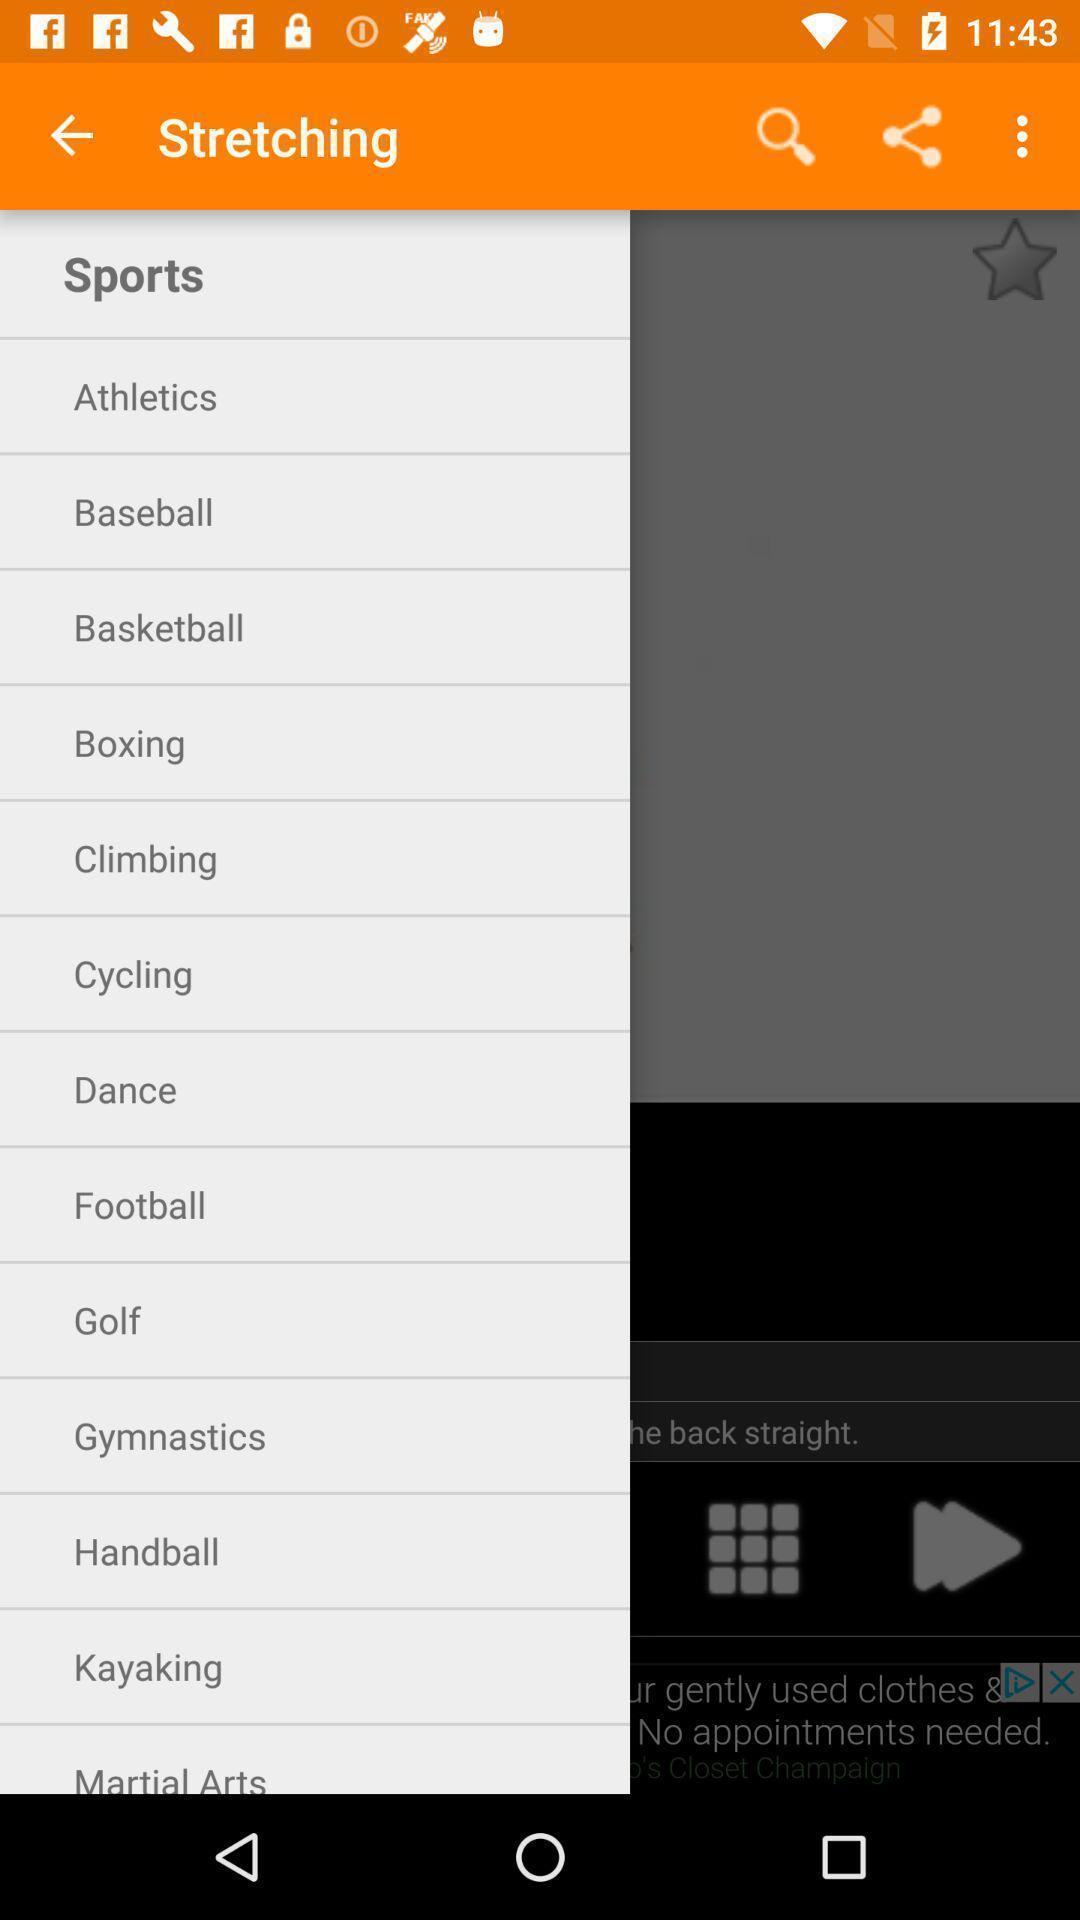Tell me about the visual elements in this screen capture. Screen displaying the the more menu with multiple options. 